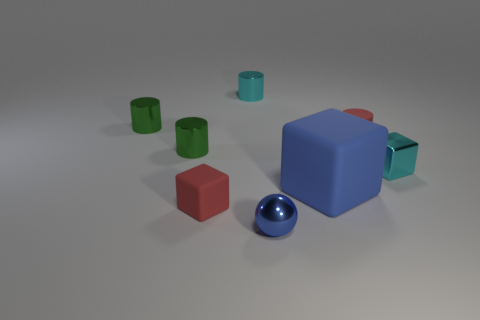How many blue spheres are there?
Provide a short and direct response. 1. How many tiny things are on the left side of the big cube and behind the cyan block?
Provide a short and direct response. 3. What is the tiny ball made of?
Provide a succinct answer. Metal. Is there a big blue block?
Provide a succinct answer. Yes. There is a large thing that is on the left side of the red cylinder; what is its color?
Offer a terse response. Blue. There is a tiny green thing that is behind the matte object that is behind the small cyan block; what number of small blue shiny objects are to the left of it?
Provide a succinct answer. 0. The tiny object that is on the right side of the large blue block and to the left of the tiny metallic cube is made of what material?
Offer a very short reply. Rubber. Does the big blue object have the same material as the small block on the right side of the small ball?
Give a very brief answer. No. Are there more blue metal balls behind the small cyan metal cube than tiny green objects that are on the right side of the big blue rubber object?
Give a very brief answer. No. What shape is the tiny blue metal thing?
Give a very brief answer. Sphere. 